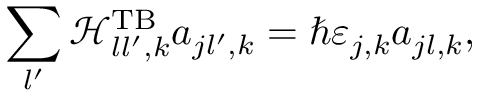Convert formula to latex. <formula><loc_0><loc_0><loc_500><loc_500>\sum _ { l ^ { \prime } } \mathcal { H } _ { l l ^ { \prime } , k } ^ { T B } a _ { j l ^ { \prime } , k } = \hbar { \varepsilon } _ { j , k } a _ { j l , k } ,</formula> 